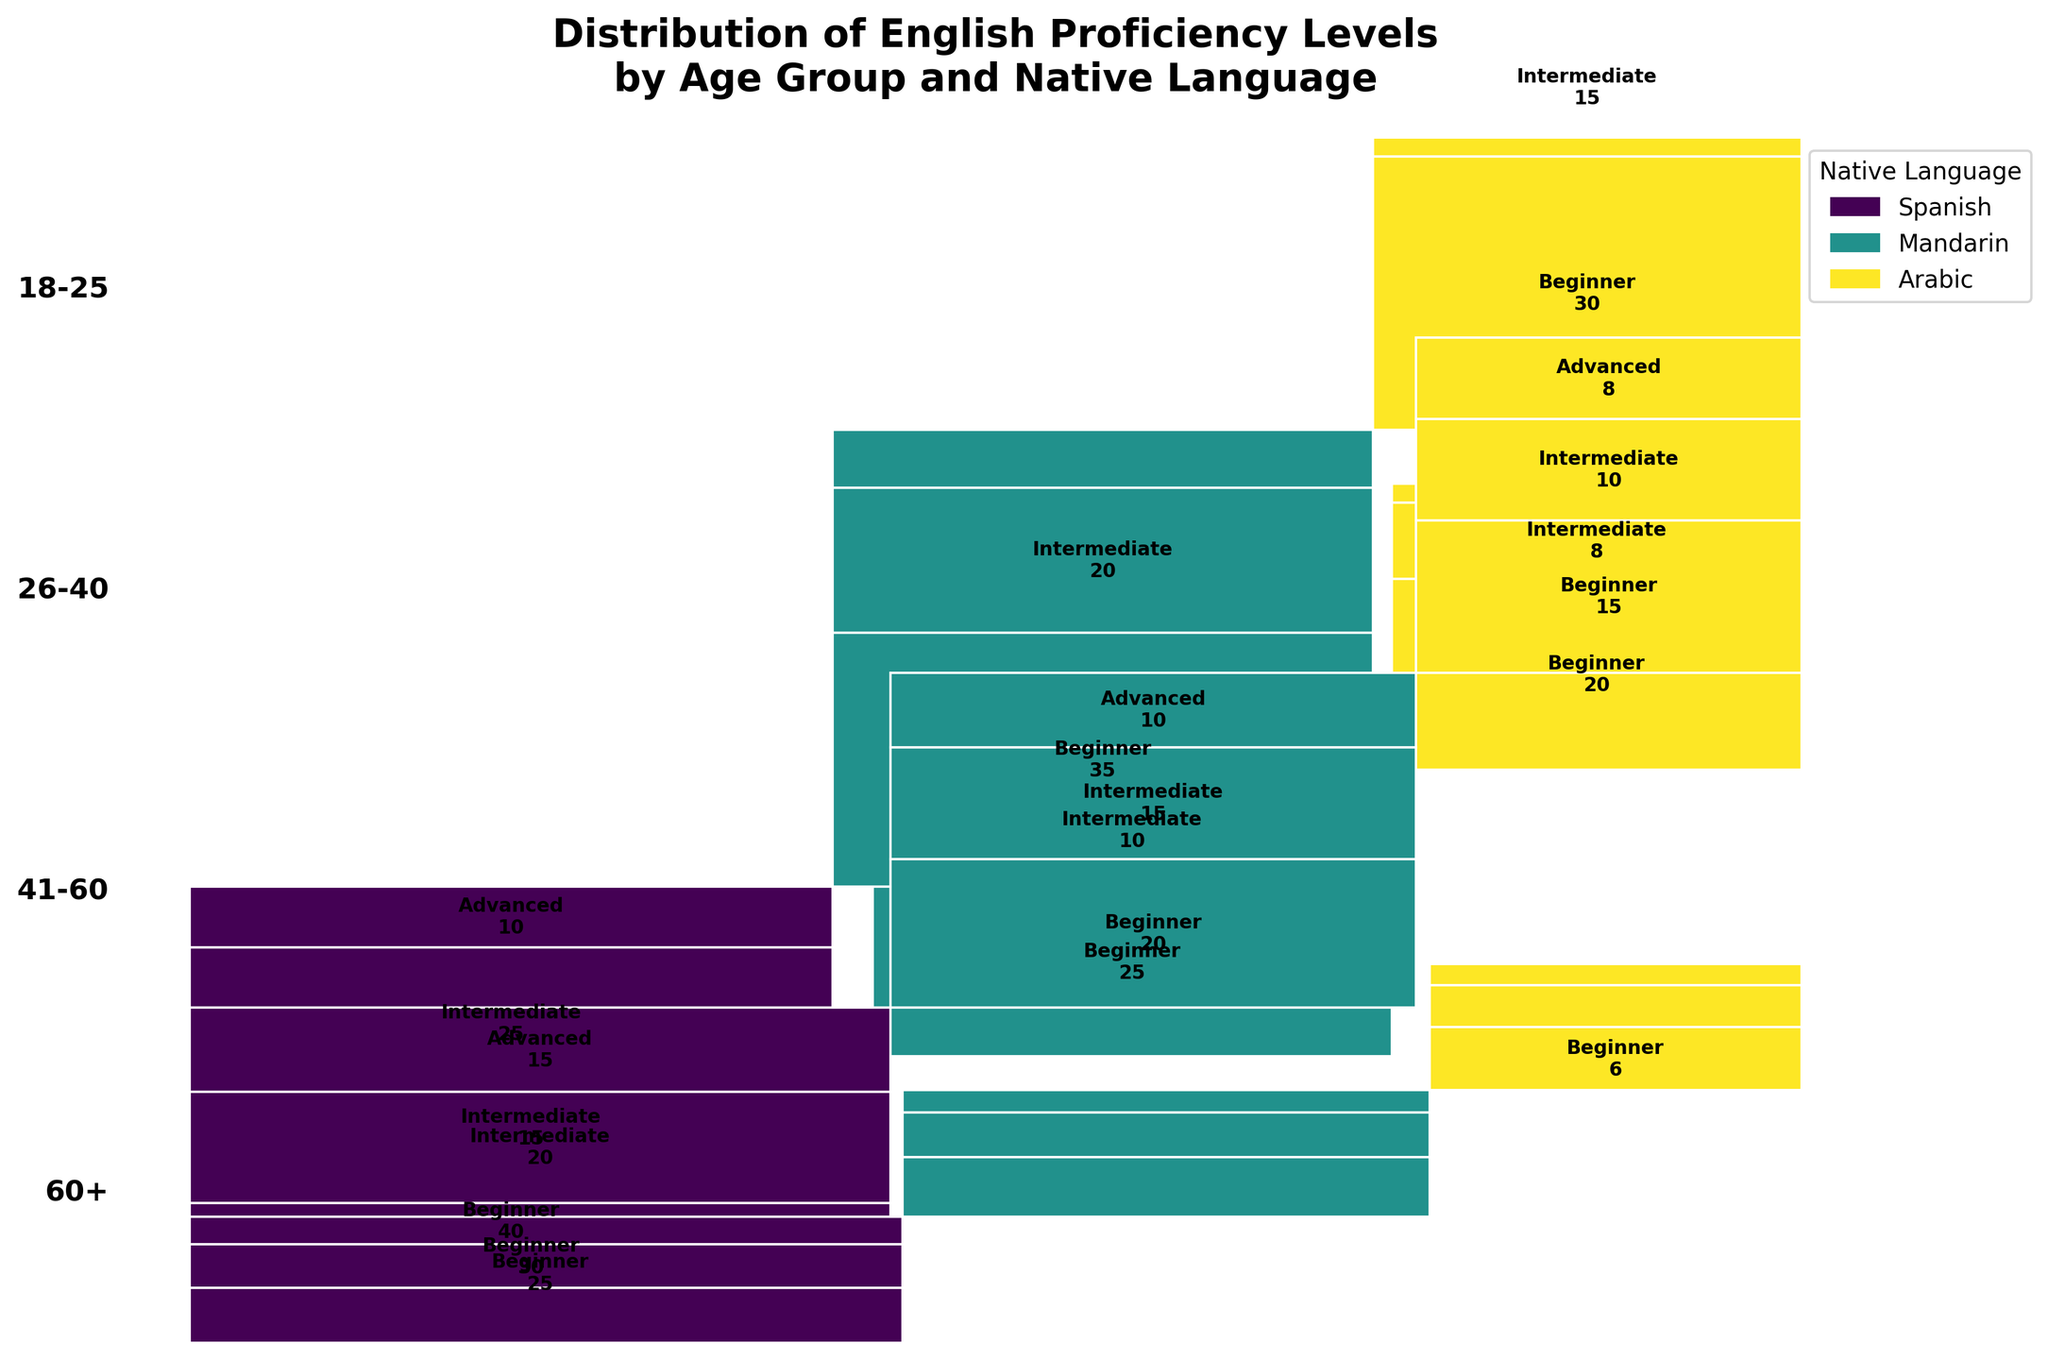What's the title of the figure? The title of the plot is usually placed at the top and provides a summary of what the plot represents. Here, the title is 'Distribution of English Proficiency Levels by Age Group and Native Language'.
Answer: Distribution of English Proficiency Levels by Age Group and Native Language Which age group has the highest number of Beginners for Spanish speakers? The Mosaic Plot shows the relative sizes of each subgroup. For Spanish speakers, the height and width of the Beginner section in different age groups should be compared. The '26-40' age group has the largest Beginner section.
Answer: 26-40 How many Intermediate students are there in the 18-25 age group who speak Mandarin? The figure shows sub-segments for each proficiency level. For the 18-25 age group and Mandarin speakers, the labeled Intermediate section indicates the count.
Answer: 10 Which proficiency level has the smallest proportion within the '60+' age group for Arabic speakers? Compare the relative sizes of the Beginner, Intermediate, and Advanced sections for Arabic speakers in the '60+' age group. The Advanced section is the smallest.
Answer: Advanced Compare the number of Advanced students between the 41-60 age group and the 60+ age group for Spanish speakers. Which has more? Locate the Advanced sections for Spanish speakers in the 41-60 and 60+ age groups. The total in the 41-60 age group is 15, while for the 60+ age group, it's 5. Therefore, the 41-60 age group has more.
Answer: 41-60 For which age group does Mandarin have the highest total number of students, and what is this number? Summing up the Beginners, Intermediates, and Advanced sections for Mandarin speakers in each age group, the 26-40 group has the highest total (35 Beginners + 20 Intermediates + 8 Advanced = 63).
Answer: 26-40, 63 Is there an age group where the number of Intermediate students across all languages is higher than the number of Beginners in the same age group? For each age group, compare the sum of Intermediate students (all languages) to Beginners. The '41-60' group has more Intermediate students across all languages (20+15+10=45) than Beginners (25+20+15=60), so no, there isn't.
Answer: No What pattern is visible concerning the proficiency level distribution among different age groups for Arabic speakers? Analyze the proportion of Beginner, Intermediate, and Advanced levels for Arabic speakers in each age group. For Arabic speakers, the number of Beginners decreases while Intermediate and Advanced increase with age.
Answer: Beginners decrease, Intermediate and Advanced increase 